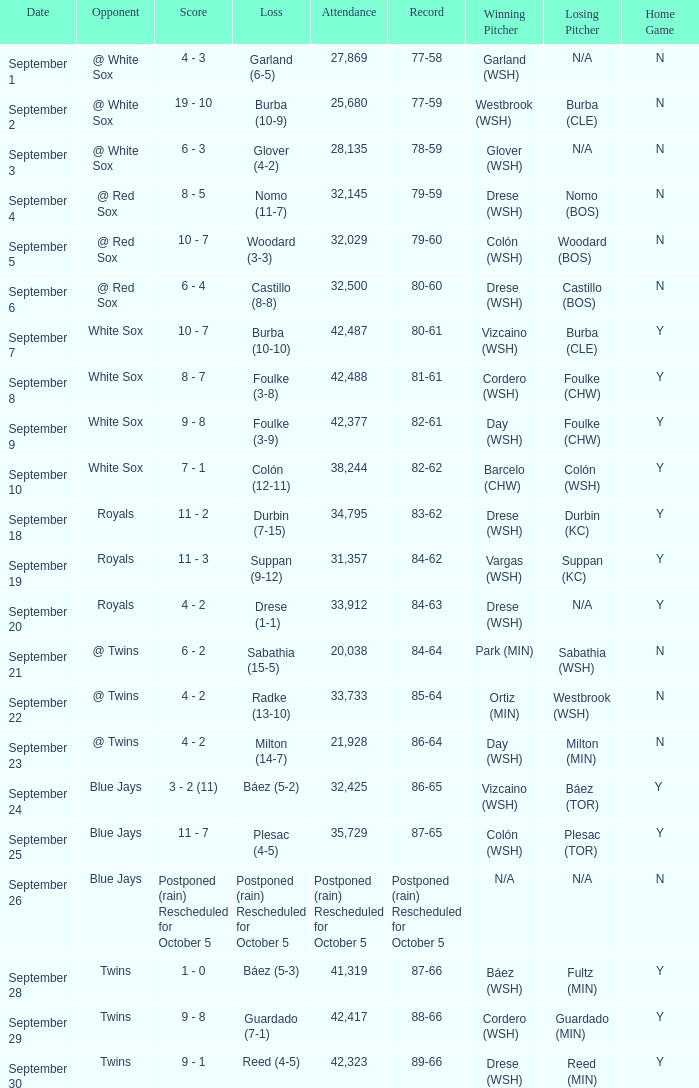What is the record of the game with 28,135 people in attendance? 78-59. 